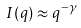<formula> <loc_0><loc_0><loc_500><loc_500>I ( q ) \approx q ^ { - \gamma }</formula> 